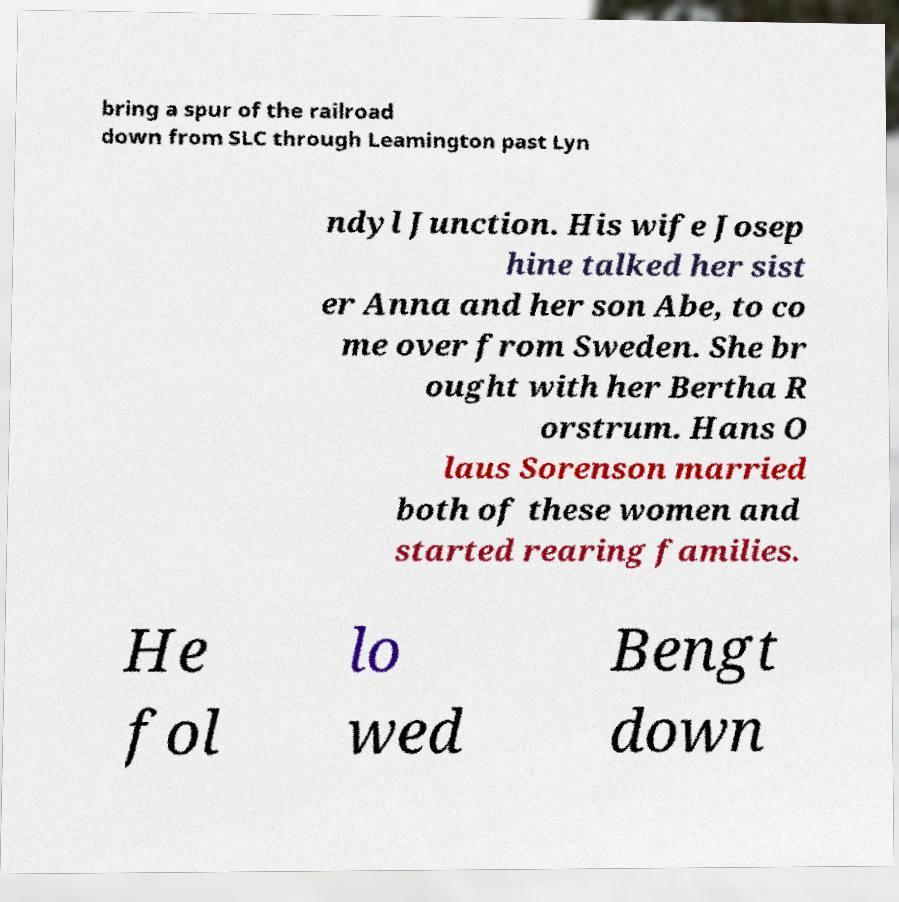Could you extract and type out the text from this image? bring a spur of the railroad down from SLC through Leamington past Lyn ndyl Junction. His wife Josep hine talked her sist er Anna and her son Abe, to co me over from Sweden. She br ought with her Bertha R orstrum. Hans O laus Sorenson married both of these women and started rearing families. He fol lo wed Bengt down 